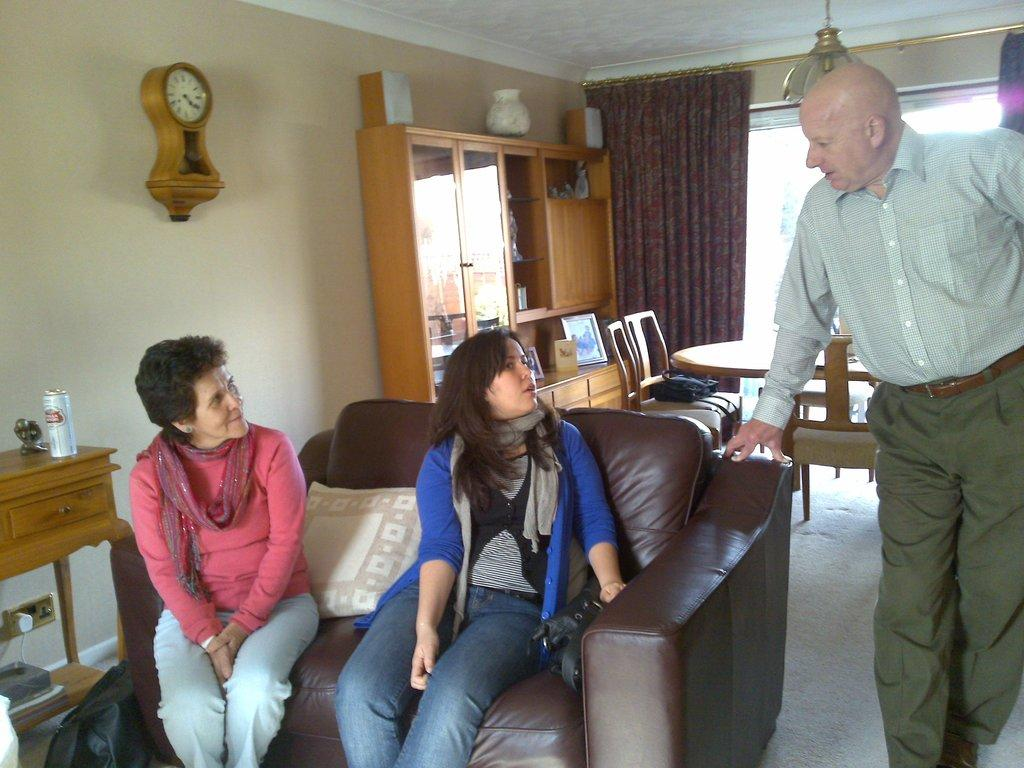What type of structure can be seen in the image? There is a wall in the image. What object is used for measuring time in the image? There is a clock in the image. What type of window treatment is present in the image? There is a curtain in the image. How many people are sitting on the sofa in the image? There are two people sitting on a sofa in the image. What is the man in the image doing? There is a man standing in the image. What type of furniture is present for eating in the image? There is a dining table in the image. How many knots are tied in the curtain in the image? There is no mention of knots in the curtain in the image; it is simply a curtain. What level of difficulty is the man attempting in the image? There is no indication of any difficulty level or activity being performed by the man in the image; he is simply standing. 